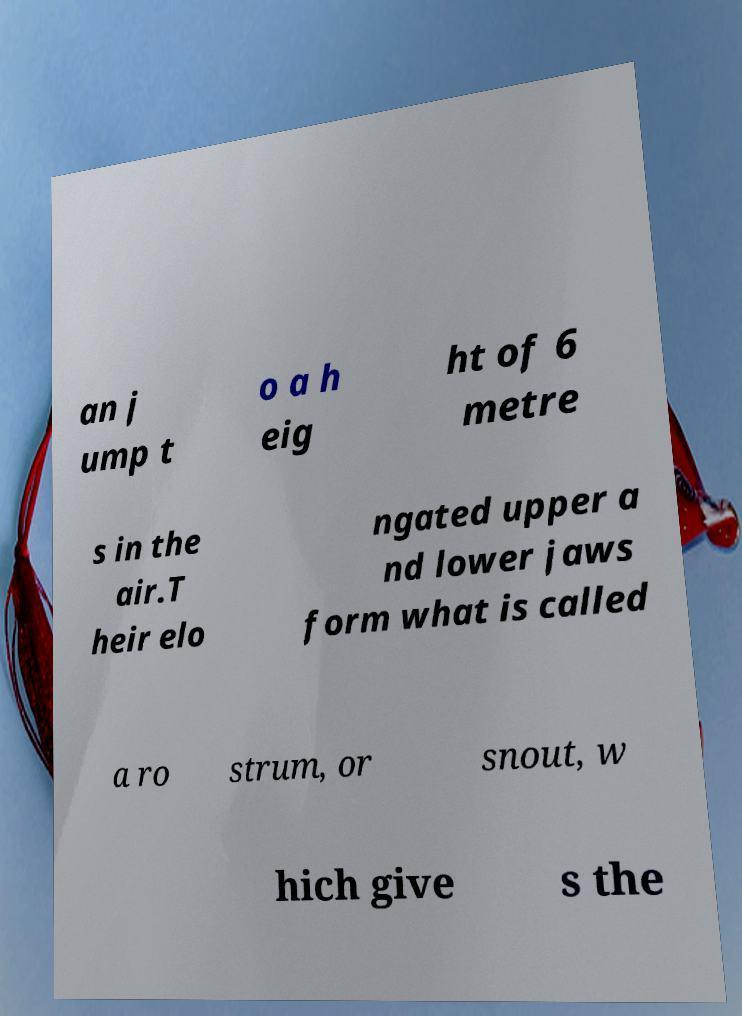What messages or text are displayed in this image? I need them in a readable, typed format. an j ump t o a h eig ht of 6 metre s in the air.T heir elo ngated upper a nd lower jaws form what is called a ro strum, or snout, w hich give s the 